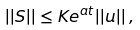Convert formula to latex. <formula><loc_0><loc_0><loc_500><loc_500>| | S | | \leq K e ^ { a t } | | u | | \, ,</formula> 